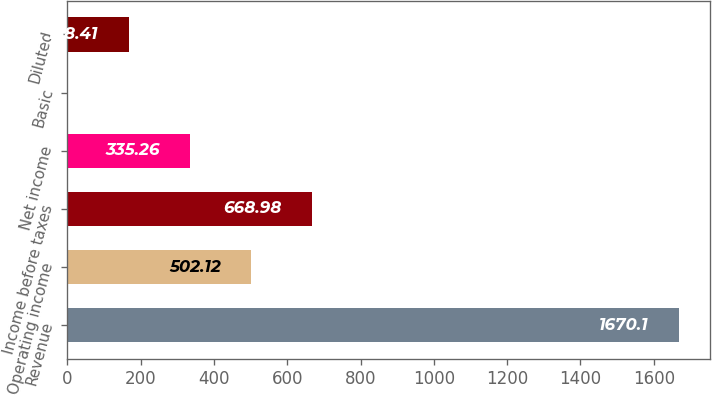<chart> <loc_0><loc_0><loc_500><loc_500><bar_chart><fcel>Revenue<fcel>Operating income<fcel>Income before taxes<fcel>Net income<fcel>Basic<fcel>Diluted<nl><fcel>1670.1<fcel>502.12<fcel>668.98<fcel>335.26<fcel>1.55<fcel>168.41<nl></chart> 